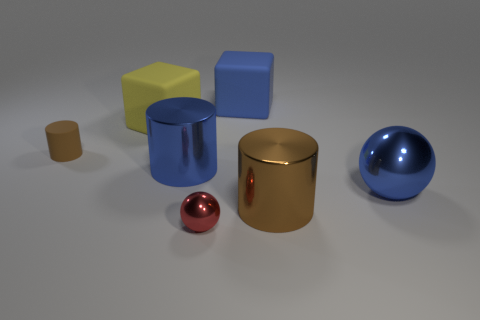Add 3 big rubber things. How many objects exist? 10 Subtract all cylinders. How many objects are left? 4 Subtract all small gray shiny objects. Subtract all big blue cylinders. How many objects are left? 6 Add 6 small brown matte things. How many small brown matte things are left? 7 Add 6 yellow matte cubes. How many yellow matte cubes exist? 7 Subtract 0 purple balls. How many objects are left? 7 